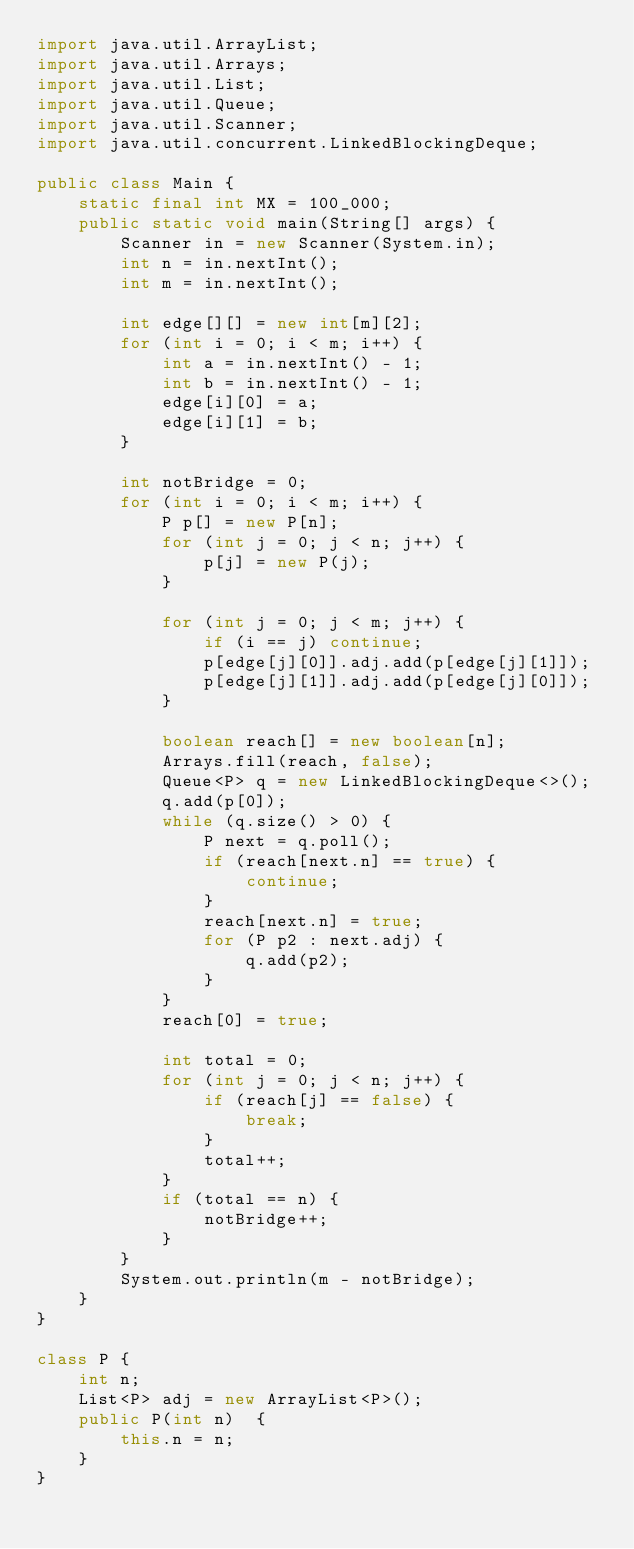Convert code to text. <code><loc_0><loc_0><loc_500><loc_500><_Java_>import java.util.ArrayList;
import java.util.Arrays;
import java.util.List;
import java.util.Queue;
import java.util.Scanner;
import java.util.concurrent.LinkedBlockingDeque;

public class Main {
    static final int MX = 100_000;
    public static void main(String[] args) {
        Scanner in = new Scanner(System.in);
        int n = in.nextInt();
        int m = in.nextInt();

        int edge[][] = new int[m][2];
        for (int i = 0; i < m; i++) {
            int a = in.nextInt() - 1;
            int b = in.nextInt() - 1;
            edge[i][0] = a;
            edge[i][1] = b;
        }

        int notBridge = 0;
        for (int i = 0; i < m; i++) {
            P p[] = new P[n];
            for (int j = 0; j < n; j++) {
                p[j] = new P(j);
            }

            for (int j = 0; j < m; j++) {
                if (i == j) continue;
                p[edge[j][0]].adj.add(p[edge[j][1]]);
                p[edge[j][1]].adj.add(p[edge[j][0]]);
            }

            boolean reach[] = new boolean[n];
            Arrays.fill(reach, false);
            Queue<P> q = new LinkedBlockingDeque<>();
            q.add(p[0]);
            while (q.size() > 0) {
                P next = q.poll();
                if (reach[next.n] == true) {
                    continue;
                }
                reach[next.n] = true;
                for (P p2 : next.adj) {
                    q.add(p2);
                }
            }
            reach[0] = true;

            int total = 0;
            for (int j = 0; j < n; j++) {
                if (reach[j] == false) {
                    break;
                }
                total++;
            }
            if (total == n) {
                notBridge++;
            }
        }
        System.out.println(m - notBridge);
    }
}

class P {
    int n;
    List<P> adj = new ArrayList<P>();
    public P(int n)  {
        this.n = n;
    }
}</code> 